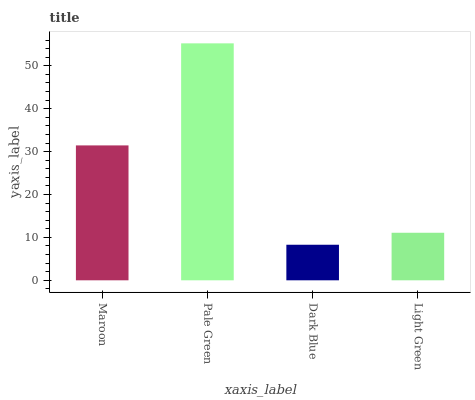Is Pale Green the minimum?
Answer yes or no. No. Is Dark Blue the maximum?
Answer yes or no. No. Is Pale Green greater than Dark Blue?
Answer yes or no. Yes. Is Dark Blue less than Pale Green?
Answer yes or no. Yes. Is Dark Blue greater than Pale Green?
Answer yes or no. No. Is Pale Green less than Dark Blue?
Answer yes or no. No. Is Maroon the high median?
Answer yes or no. Yes. Is Light Green the low median?
Answer yes or no. Yes. Is Pale Green the high median?
Answer yes or no. No. Is Dark Blue the low median?
Answer yes or no. No. 